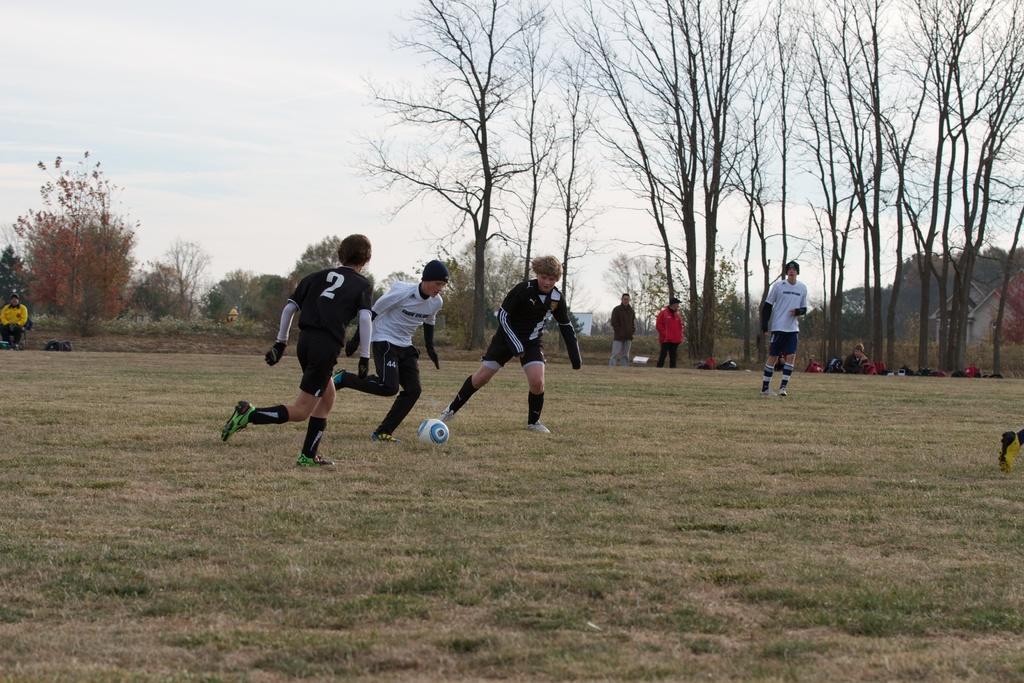Please provide a concise description of this image. These three people are playing football, as there is a movement in their legs and a ball is on ground. Far there are number of trees and bare trees. These three persons are standing. Far this person is sitting on a bench. We can able to see a building. 